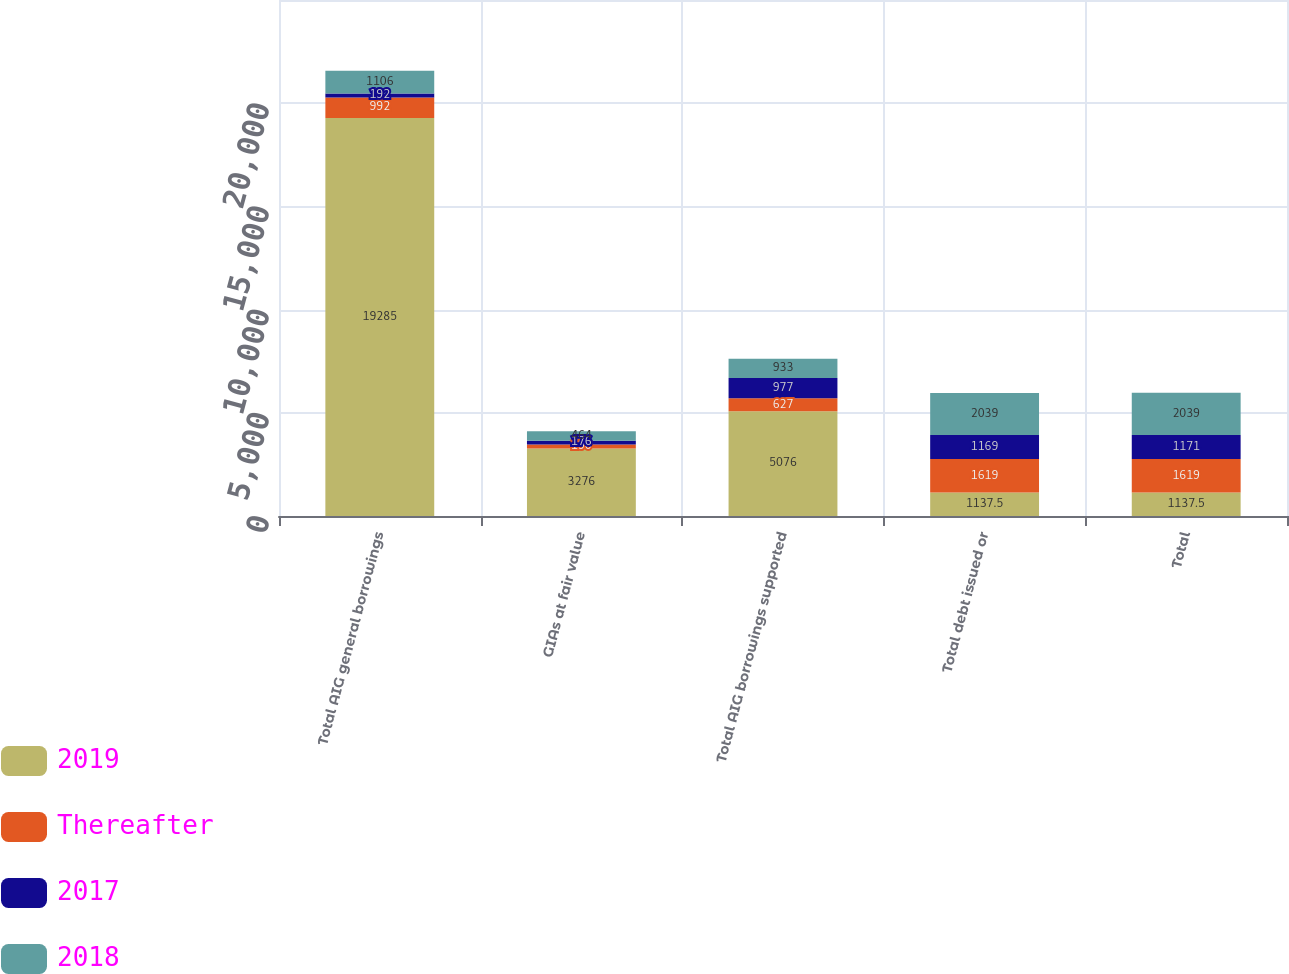Convert chart. <chart><loc_0><loc_0><loc_500><loc_500><stacked_bar_chart><ecel><fcel>Total AIG general borrowings<fcel>GIAs at fair value<fcel>Total AIG borrowings supported<fcel>Total debt issued or<fcel>Total<nl><fcel>2019<fcel>19285<fcel>3276<fcel>5076<fcel>1137.5<fcel>1137.5<nl><fcel>Thereafter<fcel>992<fcel>190<fcel>627<fcel>1619<fcel>1619<nl><fcel>2017<fcel>192<fcel>176<fcel>977<fcel>1169<fcel>1171<nl><fcel>2018<fcel>1106<fcel>464<fcel>933<fcel>2039<fcel>2039<nl></chart> 